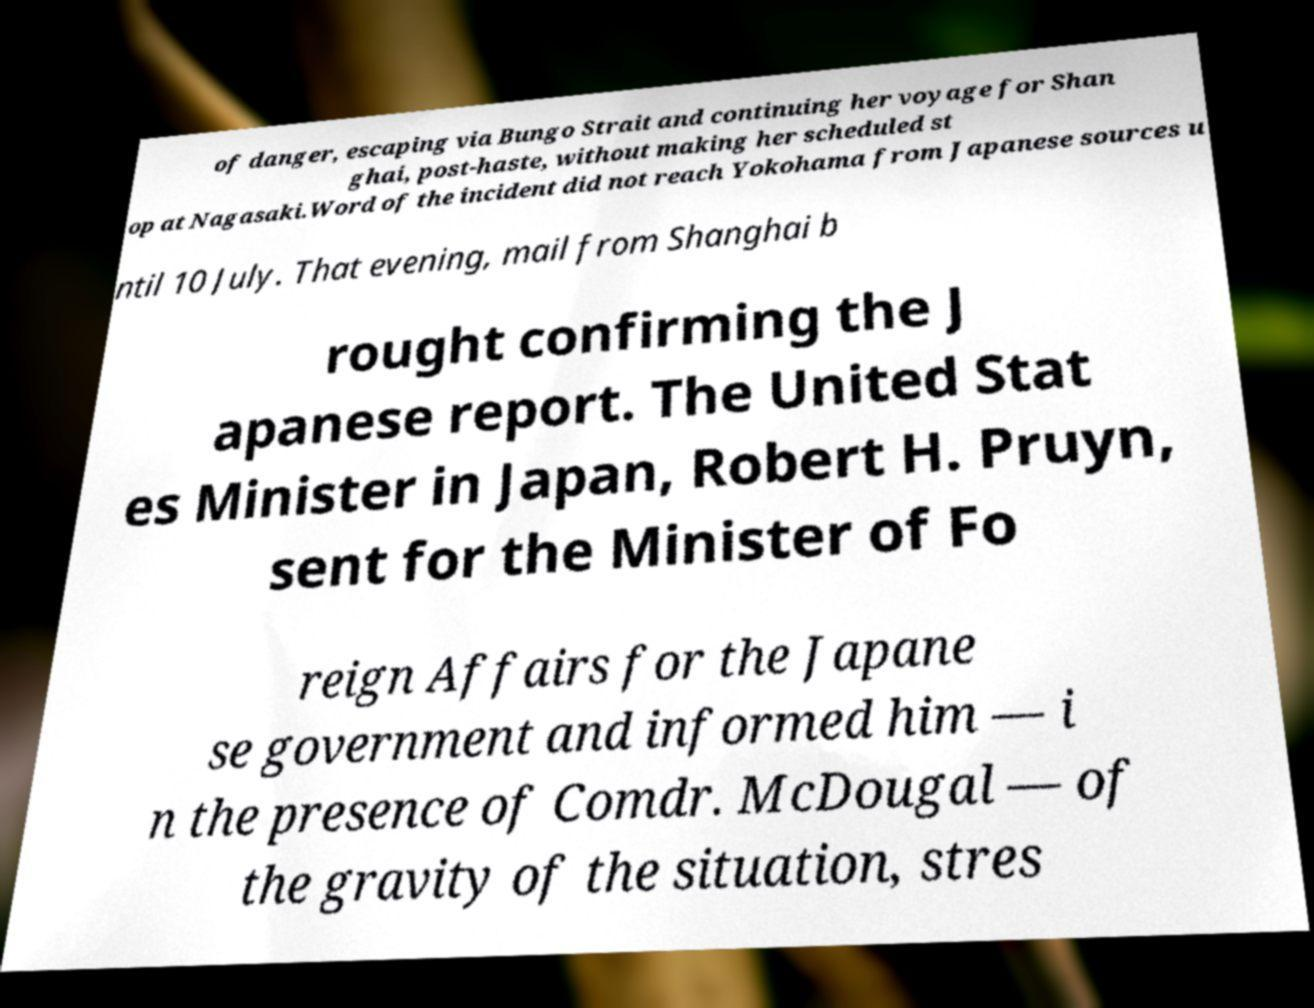Please read and relay the text visible in this image. What does it say? of danger, escaping via Bungo Strait and continuing her voyage for Shan ghai, post-haste, without making her scheduled st op at Nagasaki.Word of the incident did not reach Yokohama from Japanese sources u ntil 10 July. That evening, mail from Shanghai b rought confirming the J apanese report. The United Stat es Minister in Japan, Robert H. Pruyn, sent for the Minister of Fo reign Affairs for the Japane se government and informed him — i n the presence of Comdr. McDougal — of the gravity of the situation, stres 